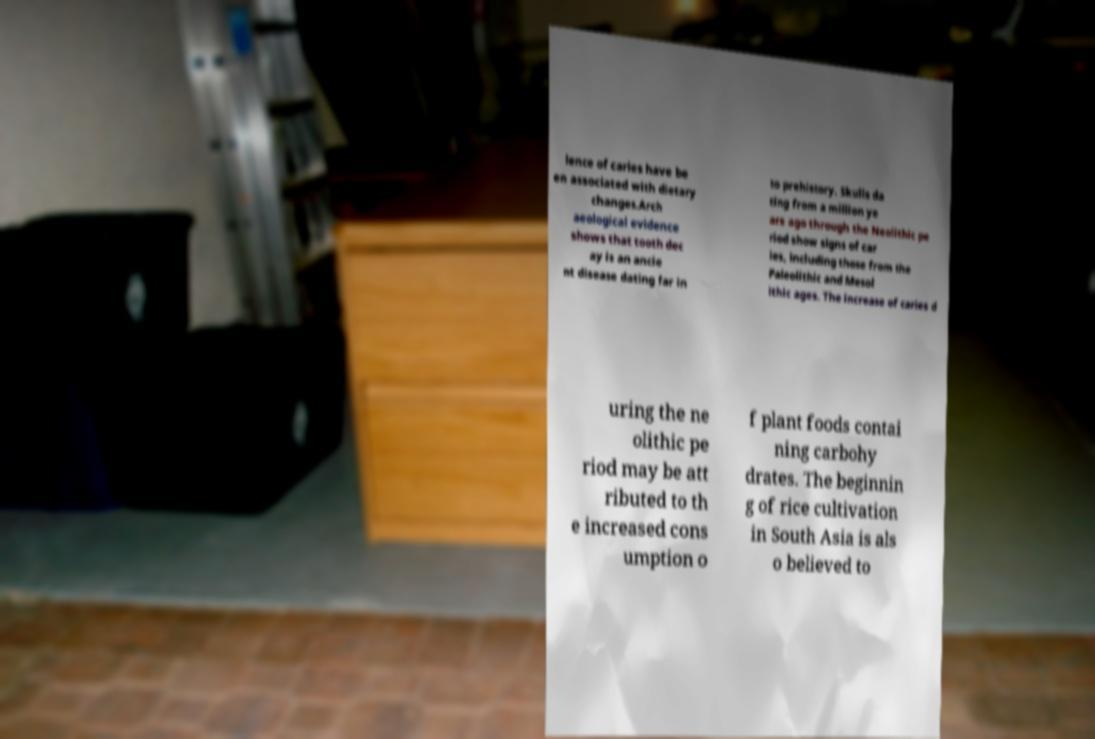Could you extract and type out the text from this image? lence of caries have be en associated with dietary changes.Arch aeological evidence shows that tooth dec ay is an ancie nt disease dating far in to prehistory. Skulls da ting from a million ye ars ago through the Neolithic pe riod show signs of car ies, including those from the Paleolithic and Mesol ithic ages. The increase of caries d uring the ne olithic pe riod may be att ributed to th e increased cons umption o f plant foods contai ning carbohy drates. The beginnin g of rice cultivation in South Asia is als o believed to 